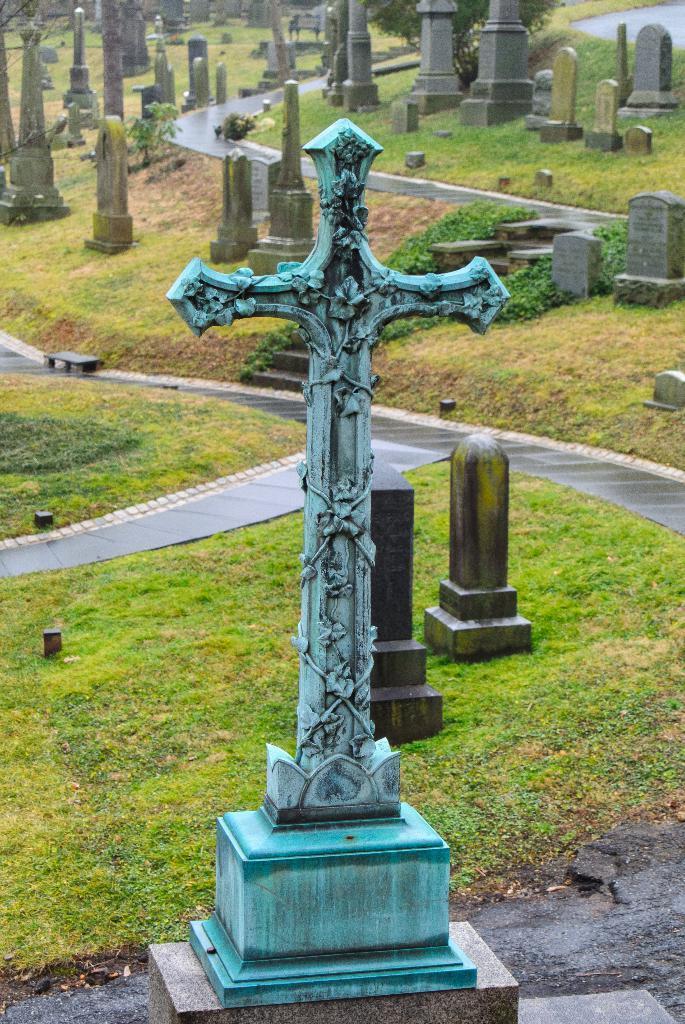Describe this image in one or two sentences. In this image we can see cross with sculptures. And it is on a pedestal. In the back there are graves. On the ground there is grass. Also there are roads. 